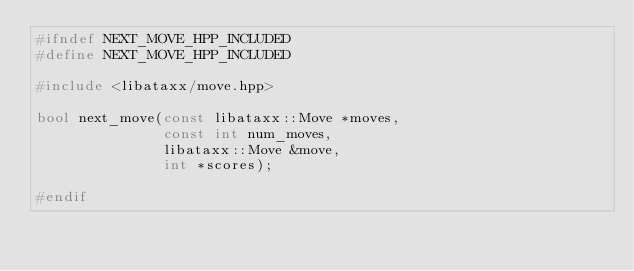<code> <loc_0><loc_0><loc_500><loc_500><_C++_>#ifndef NEXT_MOVE_HPP_INCLUDED
#define NEXT_MOVE_HPP_INCLUDED

#include <libataxx/move.hpp>

bool next_move(const libataxx::Move *moves,
               const int num_moves,
               libataxx::Move &move,
               int *scores);

#endif
</code> 